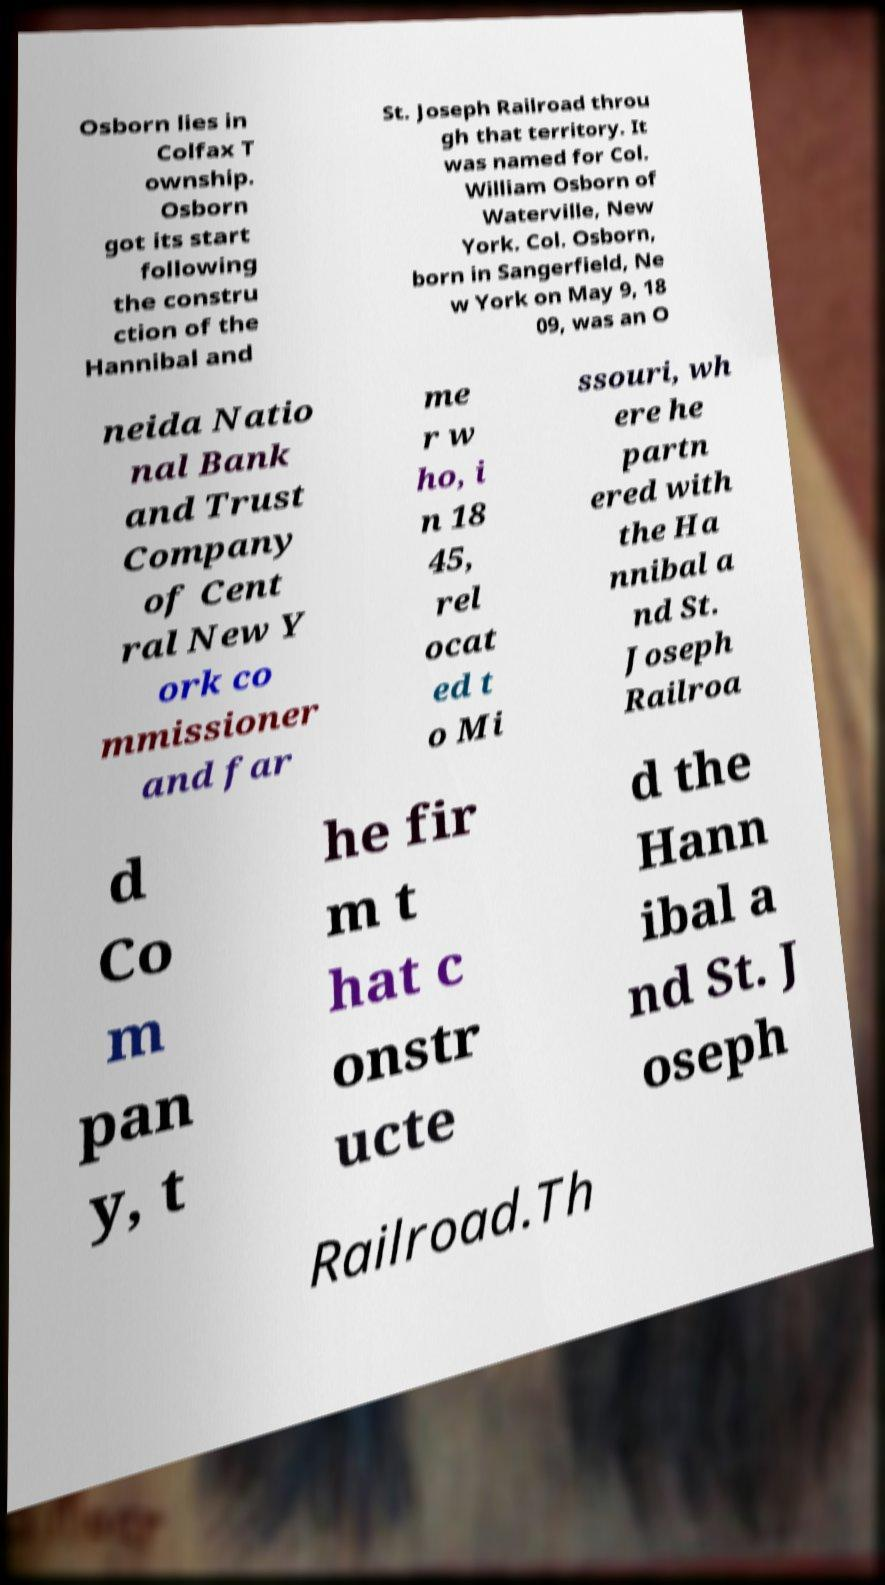Please read and relay the text visible in this image. What does it say? Osborn lies in Colfax T ownship. Osborn got its start following the constru ction of the Hannibal and St. Joseph Railroad throu gh that territory. It was named for Col. William Osborn of Waterville, New York. Col. Osborn, born in Sangerfield, Ne w York on May 9, 18 09, was an O neida Natio nal Bank and Trust Company of Cent ral New Y ork co mmissioner and far me r w ho, i n 18 45, rel ocat ed t o Mi ssouri, wh ere he partn ered with the Ha nnibal a nd St. Joseph Railroa d Co m pan y, t he fir m t hat c onstr ucte d the Hann ibal a nd St. J oseph Railroad.Th 